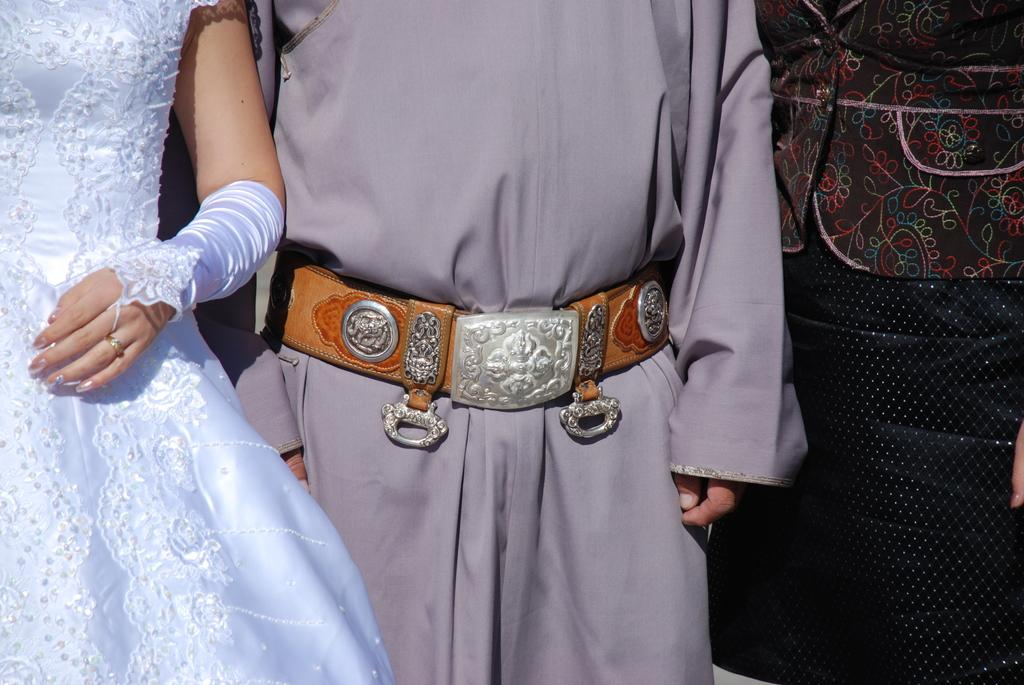How many individuals are present in the image? There are two people in the image. Can you describe the objects visible behind the people? Unfortunately, the provided facts do not give any information about the objects behind the people. What type of glue is being used by the people in the image? There is no glue present in the image, and therefore no such activity can be observed. 